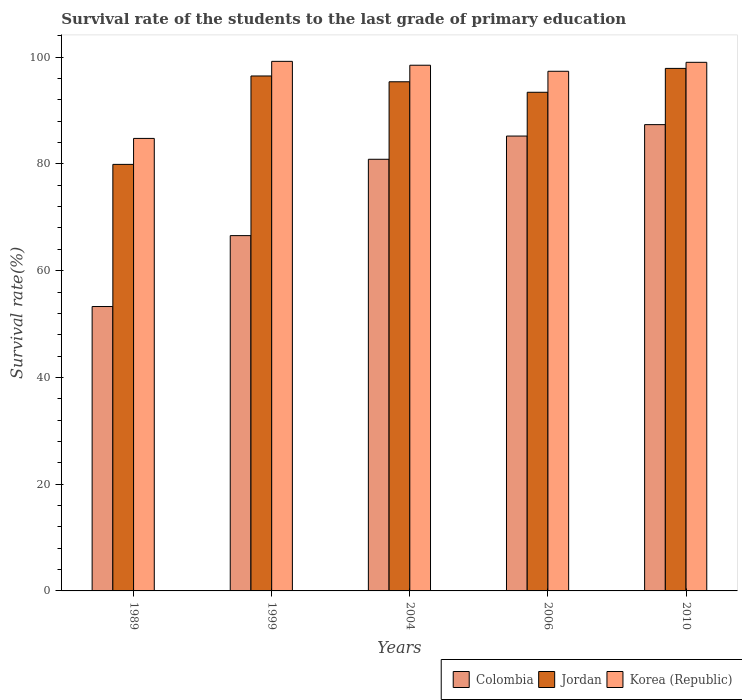Are the number of bars on each tick of the X-axis equal?
Offer a terse response. Yes. How many bars are there on the 4th tick from the left?
Offer a very short reply. 3. What is the label of the 1st group of bars from the left?
Ensure brevity in your answer.  1989. In how many cases, is the number of bars for a given year not equal to the number of legend labels?
Provide a short and direct response. 0. What is the survival rate of the students in Colombia in 2004?
Your response must be concise. 80.87. Across all years, what is the maximum survival rate of the students in Korea (Republic)?
Ensure brevity in your answer.  99.22. Across all years, what is the minimum survival rate of the students in Jordan?
Keep it short and to the point. 79.92. What is the total survival rate of the students in Colombia in the graph?
Your answer should be compact. 373.31. What is the difference between the survival rate of the students in Colombia in 1989 and that in 2004?
Give a very brief answer. -27.59. What is the difference between the survival rate of the students in Jordan in 2010 and the survival rate of the students in Korea (Republic) in 2004?
Offer a terse response. -0.59. What is the average survival rate of the students in Korea (Republic) per year?
Ensure brevity in your answer.  95.78. In the year 2010, what is the difference between the survival rate of the students in Korea (Republic) and survival rate of the students in Jordan?
Make the answer very short. 1.14. In how many years, is the survival rate of the students in Colombia greater than 100 %?
Provide a succinct answer. 0. What is the ratio of the survival rate of the students in Colombia in 1989 to that in 2006?
Make the answer very short. 0.63. Is the survival rate of the students in Jordan in 1989 less than that in 2010?
Provide a short and direct response. Yes. Is the difference between the survival rate of the students in Korea (Republic) in 2006 and 2010 greater than the difference between the survival rate of the students in Jordan in 2006 and 2010?
Your answer should be compact. Yes. What is the difference between the highest and the second highest survival rate of the students in Korea (Republic)?
Provide a succinct answer. 0.18. What is the difference between the highest and the lowest survival rate of the students in Korea (Republic)?
Make the answer very short. 14.44. In how many years, is the survival rate of the students in Jordan greater than the average survival rate of the students in Jordan taken over all years?
Provide a short and direct response. 4. Is the sum of the survival rate of the students in Korea (Republic) in 1999 and 2004 greater than the maximum survival rate of the students in Jordan across all years?
Your answer should be compact. Yes. What does the 2nd bar from the left in 1989 represents?
Keep it short and to the point. Jordan. Are all the bars in the graph horizontal?
Your answer should be compact. No. Does the graph contain any zero values?
Ensure brevity in your answer.  No. How are the legend labels stacked?
Your answer should be very brief. Horizontal. What is the title of the graph?
Provide a short and direct response. Survival rate of the students to the last grade of primary education. Does "Mexico" appear as one of the legend labels in the graph?
Offer a terse response. No. What is the label or title of the Y-axis?
Keep it short and to the point. Survival rate(%). What is the Survival rate(%) in Colombia in 1989?
Give a very brief answer. 53.28. What is the Survival rate(%) of Jordan in 1989?
Your response must be concise. 79.92. What is the Survival rate(%) of Korea (Republic) in 1989?
Your answer should be compact. 84.78. What is the Survival rate(%) of Colombia in 1999?
Your answer should be compact. 66.57. What is the Survival rate(%) in Jordan in 1999?
Your answer should be compact. 96.48. What is the Survival rate(%) in Korea (Republic) in 1999?
Your answer should be compact. 99.22. What is the Survival rate(%) in Colombia in 2004?
Provide a short and direct response. 80.87. What is the Survival rate(%) of Jordan in 2004?
Make the answer very short. 95.39. What is the Survival rate(%) of Korea (Republic) in 2004?
Keep it short and to the point. 98.49. What is the Survival rate(%) in Colombia in 2006?
Provide a succinct answer. 85.22. What is the Survival rate(%) of Jordan in 2006?
Provide a succinct answer. 93.43. What is the Survival rate(%) in Korea (Republic) in 2006?
Provide a succinct answer. 97.36. What is the Survival rate(%) of Colombia in 2010?
Your answer should be compact. 87.36. What is the Survival rate(%) of Jordan in 2010?
Your answer should be very brief. 97.9. What is the Survival rate(%) of Korea (Republic) in 2010?
Make the answer very short. 99.04. Across all years, what is the maximum Survival rate(%) of Colombia?
Offer a terse response. 87.36. Across all years, what is the maximum Survival rate(%) of Jordan?
Give a very brief answer. 97.9. Across all years, what is the maximum Survival rate(%) of Korea (Republic)?
Your answer should be compact. 99.22. Across all years, what is the minimum Survival rate(%) of Colombia?
Your response must be concise. 53.28. Across all years, what is the minimum Survival rate(%) in Jordan?
Make the answer very short. 79.92. Across all years, what is the minimum Survival rate(%) of Korea (Republic)?
Provide a short and direct response. 84.78. What is the total Survival rate(%) of Colombia in the graph?
Your answer should be very brief. 373.31. What is the total Survival rate(%) of Jordan in the graph?
Your answer should be compact. 463.11. What is the total Survival rate(%) in Korea (Republic) in the graph?
Provide a succinct answer. 478.89. What is the difference between the Survival rate(%) of Colombia in 1989 and that in 1999?
Make the answer very short. -13.29. What is the difference between the Survival rate(%) of Jordan in 1989 and that in 1999?
Offer a terse response. -16.56. What is the difference between the Survival rate(%) in Korea (Republic) in 1989 and that in 1999?
Your answer should be very brief. -14.44. What is the difference between the Survival rate(%) in Colombia in 1989 and that in 2004?
Your answer should be compact. -27.59. What is the difference between the Survival rate(%) in Jordan in 1989 and that in 2004?
Provide a succinct answer. -15.48. What is the difference between the Survival rate(%) of Korea (Republic) in 1989 and that in 2004?
Offer a terse response. -13.71. What is the difference between the Survival rate(%) in Colombia in 1989 and that in 2006?
Your answer should be compact. -31.94. What is the difference between the Survival rate(%) in Jordan in 1989 and that in 2006?
Offer a very short reply. -13.51. What is the difference between the Survival rate(%) in Korea (Republic) in 1989 and that in 2006?
Your answer should be compact. -12.58. What is the difference between the Survival rate(%) of Colombia in 1989 and that in 2010?
Provide a succinct answer. -34.08. What is the difference between the Survival rate(%) of Jordan in 1989 and that in 2010?
Provide a short and direct response. -17.98. What is the difference between the Survival rate(%) of Korea (Republic) in 1989 and that in 2010?
Give a very brief answer. -14.26. What is the difference between the Survival rate(%) of Colombia in 1999 and that in 2004?
Your response must be concise. -14.3. What is the difference between the Survival rate(%) in Jordan in 1999 and that in 2004?
Ensure brevity in your answer.  1.09. What is the difference between the Survival rate(%) of Korea (Republic) in 1999 and that in 2004?
Make the answer very short. 0.72. What is the difference between the Survival rate(%) in Colombia in 1999 and that in 2006?
Provide a short and direct response. -18.65. What is the difference between the Survival rate(%) in Jordan in 1999 and that in 2006?
Provide a short and direct response. 3.05. What is the difference between the Survival rate(%) of Korea (Republic) in 1999 and that in 2006?
Make the answer very short. 1.86. What is the difference between the Survival rate(%) of Colombia in 1999 and that in 2010?
Offer a very short reply. -20.79. What is the difference between the Survival rate(%) of Jordan in 1999 and that in 2010?
Offer a very short reply. -1.42. What is the difference between the Survival rate(%) in Korea (Republic) in 1999 and that in 2010?
Give a very brief answer. 0.18. What is the difference between the Survival rate(%) in Colombia in 2004 and that in 2006?
Your response must be concise. -4.35. What is the difference between the Survival rate(%) in Jordan in 2004 and that in 2006?
Make the answer very short. 1.97. What is the difference between the Survival rate(%) of Korea (Republic) in 2004 and that in 2006?
Provide a short and direct response. 1.13. What is the difference between the Survival rate(%) of Colombia in 2004 and that in 2010?
Offer a very short reply. -6.49. What is the difference between the Survival rate(%) in Jordan in 2004 and that in 2010?
Your response must be concise. -2.51. What is the difference between the Survival rate(%) of Korea (Republic) in 2004 and that in 2010?
Offer a very short reply. -0.54. What is the difference between the Survival rate(%) in Colombia in 2006 and that in 2010?
Your response must be concise. -2.14. What is the difference between the Survival rate(%) in Jordan in 2006 and that in 2010?
Provide a short and direct response. -4.47. What is the difference between the Survival rate(%) of Korea (Republic) in 2006 and that in 2010?
Offer a very short reply. -1.68. What is the difference between the Survival rate(%) of Colombia in 1989 and the Survival rate(%) of Jordan in 1999?
Provide a short and direct response. -43.19. What is the difference between the Survival rate(%) in Colombia in 1989 and the Survival rate(%) in Korea (Republic) in 1999?
Your answer should be very brief. -45.93. What is the difference between the Survival rate(%) in Jordan in 1989 and the Survival rate(%) in Korea (Republic) in 1999?
Give a very brief answer. -19.3. What is the difference between the Survival rate(%) in Colombia in 1989 and the Survival rate(%) in Jordan in 2004?
Offer a very short reply. -42.11. What is the difference between the Survival rate(%) in Colombia in 1989 and the Survival rate(%) in Korea (Republic) in 2004?
Provide a succinct answer. -45.21. What is the difference between the Survival rate(%) of Jordan in 1989 and the Survival rate(%) of Korea (Republic) in 2004?
Make the answer very short. -18.58. What is the difference between the Survival rate(%) in Colombia in 1989 and the Survival rate(%) in Jordan in 2006?
Your response must be concise. -40.14. What is the difference between the Survival rate(%) of Colombia in 1989 and the Survival rate(%) of Korea (Republic) in 2006?
Keep it short and to the point. -44.08. What is the difference between the Survival rate(%) in Jordan in 1989 and the Survival rate(%) in Korea (Republic) in 2006?
Provide a succinct answer. -17.44. What is the difference between the Survival rate(%) of Colombia in 1989 and the Survival rate(%) of Jordan in 2010?
Your answer should be compact. -44.62. What is the difference between the Survival rate(%) of Colombia in 1989 and the Survival rate(%) of Korea (Republic) in 2010?
Give a very brief answer. -45.75. What is the difference between the Survival rate(%) of Jordan in 1989 and the Survival rate(%) of Korea (Republic) in 2010?
Provide a succinct answer. -19.12. What is the difference between the Survival rate(%) of Colombia in 1999 and the Survival rate(%) of Jordan in 2004?
Give a very brief answer. -28.82. What is the difference between the Survival rate(%) of Colombia in 1999 and the Survival rate(%) of Korea (Republic) in 2004?
Make the answer very short. -31.92. What is the difference between the Survival rate(%) of Jordan in 1999 and the Survival rate(%) of Korea (Republic) in 2004?
Provide a short and direct response. -2.02. What is the difference between the Survival rate(%) of Colombia in 1999 and the Survival rate(%) of Jordan in 2006?
Your answer should be very brief. -26.86. What is the difference between the Survival rate(%) in Colombia in 1999 and the Survival rate(%) in Korea (Republic) in 2006?
Offer a very short reply. -30.79. What is the difference between the Survival rate(%) of Jordan in 1999 and the Survival rate(%) of Korea (Republic) in 2006?
Your answer should be very brief. -0.88. What is the difference between the Survival rate(%) of Colombia in 1999 and the Survival rate(%) of Jordan in 2010?
Your answer should be very brief. -31.33. What is the difference between the Survival rate(%) of Colombia in 1999 and the Survival rate(%) of Korea (Republic) in 2010?
Your answer should be very brief. -32.47. What is the difference between the Survival rate(%) in Jordan in 1999 and the Survival rate(%) in Korea (Republic) in 2010?
Offer a very short reply. -2.56. What is the difference between the Survival rate(%) of Colombia in 2004 and the Survival rate(%) of Jordan in 2006?
Ensure brevity in your answer.  -12.55. What is the difference between the Survival rate(%) of Colombia in 2004 and the Survival rate(%) of Korea (Republic) in 2006?
Your response must be concise. -16.49. What is the difference between the Survival rate(%) of Jordan in 2004 and the Survival rate(%) of Korea (Republic) in 2006?
Your answer should be compact. -1.97. What is the difference between the Survival rate(%) in Colombia in 2004 and the Survival rate(%) in Jordan in 2010?
Your response must be concise. -17.03. What is the difference between the Survival rate(%) in Colombia in 2004 and the Survival rate(%) in Korea (Republic) in 2010?
Offer a terse response. -18.16. What is the difference between the Survival rate(%) in Jordan in 2004 and the Survival rate(%) in Korea (Republic) in 2010?
Your answer should be compact. -3.65. What is the difference between the Survival rate(%) of Colombia in 2006 and the Survival rate(%) of Jordan in 2010?
Your response must be concise. -12.68. What is the difference between the Survival rate(%) in Colombia in 2006 and the Survival rate(%) in Korea (Republic) in 2010?
Provide a short and direct response. -13.81. What is the difference between the Survival rate(%) in Jordan in 2006 and the Survival rate(%) in Korea (Republic) in 2010?
Offer a very short reply. -5.61. What is the average Survival rate(%) in Colombia per year?
Ensure brevity in your answer.  74.66. What is the average Survival rate(%) of Jordan per year?
Give a very brief answer. 92.62. What is the average Survival rate(%) in Korea (Republic) per year?
Keep it short and to the point. 95.78. In the year 1989, what is the difference between the Survival rate(%) of Colombia and Survival rate(%) of Jordan?
Offer a terse response. -26.63. In the year 1989, what is the difference between the Survival rate(%) in Colombia and Survival rate(%) in Korea (Republic)?
Make the answer very short. -31.5. In the year 1989, what is the difference between the Survival rate(%) in Jordan and Survival rate(%) in Korea (Republic)?
Keep it short and to the point. -4.86. In the year 1999, what is the difference between the Survival rate(%) of Colombia and Survival rate(%) of Jordan?
Your answer should be very brief. -29.91. In the year 1999, what is the difference between the Survival rate(%) of Colombia and Survival rate(%) of Korea (Republic)?
Provide a succinct answer. -32.65. In the year 1999, what is the difference between the Survival rate(%) in Jordan and Survival rate(%) in Korea (Republic)?
Give a very brief answer. -2.74. In the year 2004, what is the difference between the Survival rate(%) of Colombia and Survival rate(%) of Jordan?
Ensure brevity in your answer.  -14.52. In the year 2004, what is the difference between the Survival rate(%) of Colombia and Survival rate(%) of Korea (Republic)?
Make the answer very short. -17.62. In the year 2004, what is the difference between the Survival rate(%) of Jordan and Survival rate(%) of Korea (Republic)?
Provide a succinct answer. -3.1. In the year 2006, what is the difference between the Survival rate(%) in Colombia and Survival rate(%) in Jordan?
Offer a very short reply. -8.2. In the year 2006, what is the difference between the Survival rate(%) in Colombia and Survival rate(%) in Korea (Republic)?
Your response must be concise. -12.14. In the year 2006, what is the difference between the Survival rate(%) of Jordan and Survival rate(%) of Korea (Republic)?
Keep it short and to the point. -3.93. In the year 2010, what is the difference between the Survival rate(%) of Colombia and Survival rate(%) of Jordan?
Your answer should be compact. -10.54. In the year 2010, what is the difference between the Survival rate(%) of Colombia and Survival rate(%) of Korea (Republic)?
Your response must be concise. -11.68. In the year 2010, what is the difference between the Survival rate(%) of Jordan and Survival rate(%) of Korea (Republic)?
Give a very brief answer. -1.14. What is the ratio of the Survival rate(%) in Colombia in 1989 to that in 1999?
Your response must be concise. 0.8. What is the ratio of the Survival rate(%) of Jordan in 1989 to that in 1999?
Provide a short and direct response. 0.83. What is the ratio of the Survival rate(%) in Korea (Republic) in 1989 to that in 1999?
Offer a terse response. 0.85. What is the ratio of the Survival rate(%) in Colombia in 1989 to that in 2004?
Give a very brief answer. 0.66. What is the ratio of the Survival rate(%) of Jordan in 1989 to that in 2004?
Keep it short and to the point. 0.84. What is the ratio of the Survival rate(%) in Korea (Republic) in 1989 to that in 2004?
Provide a short and direct response. 0.86. What is the ratio of the Survival rate(%) of Colombia in 1989 to that in 2006?
Provide a succinct answer. 0.63. What is the ratio of the Survival rate(%) of Jordan in 1989 to that in 2006?
Provide a short and direct response. 0.86. What is the ratio of the Survival rate(%) in Korea (Republic) in 1989 to that in 2006?
Ensure brevity in your answer.  0.87. What is the ratio of the Survival rate(%) in Colombia in 1989 to that in 2010?
Ensure brevity in your answer.  0.61. What is the ratio of the Survival rate(%) of Jordan in 1989 to that in 2010?
Offer a very short reply. 0.82. What is the ratio of the Survival rate(%) in Korea (Republic) in 1989 to that in 2010?
Offer a very short reply. 0.86. What is the ratio of the Survival rate(%) in Colombia in 1999 to that in 2004?
Provide a short and direct response. 0.82. What is the ratio of the Survival rate(%) in Jordan in 1999 to that in 2004?
Your answer should be very brief. 1.01. What is the ratio of the Survival rate(%) in Korea (Republic) in 1999 to that in 2004?
Your response must be concise. 1.01. What is the ratio of the Survival rate(%) of Colombia in 1999 to that in 2006?
Your answer should be compact. 0.78. What is the ratio of the Survival rate(%) in Jordan in 1999 to that in 2006?
Offer a terse response. 1.03. What is the ratio of the Survival rate(%) of Korea (Republic) in 1999 to that in 2006?
Your response must be concise. 1.02. What is the ratio of the Survival rate(%) in Colombia in 1999 to that in 2010?
Make the answer very short. 0.76. What is the ratio of the Survival rate(%) in Jordan in 1999 to that in 2010?
Provide a succinct answer. 0.99. What is the ratio of the Survival rate(%) in Korea (Republic) in 1999 to that in 2010?
Keep it short and to the point. 1. What is the ratio of the Survival rate(%) in Colombia in 2004 to that in 2006?
Offer a terse response. 0.95. What is the ratio of the Survival rate(%) in Korea (Republic) in 2004 to that in 2006?
Keep it short and to the point. 1.01. What is the ratio of the Survival rate(%) of Colombia in 2004 to that in 2010?
Offer a terse response. 0.93. What is the ratio of the Survival rate(%) of Jordan in 2004 to that in 2010?
Your answer should be compact. 0.97. What is the ratio of the Survival rate(%) in Colombia in 2006 to that in 2010?
Your response must be concise. 0.98. What is the ratio of the Survival rate(%) in Jordan in 2006 to that in 2010?
Offer a terse response. 0.95. What is the ratio of the Survival rate(%) of Korea (Republic) in 2006 to that in 2010?
Your response must be concise. 0.98. What is the difference between the highest and the second highest Survival rate(%) in Colombia?
Keep it short and to the point. 2.14. What is the difference between the highest and the second highest Survival rate(%) in Jordan?
Keep it short and to the point. 1.42. What is the difference between the highest and the second highest Survival rate(%) of Korea (Republic)?
Provide a short and direct response. 0.18. What is the difference between the highest and the lowest Survival rate(%) of Colombia?
Your response must be concise. 34.08. What is the difference between the highest and the lowest Survival rate(%) of Jordan?
Offer a terse response. 17.98. What is the difference between the highest and the lowest Survival rate(%) of Korea (Republic)?
Make the answer very short. 14.44. 